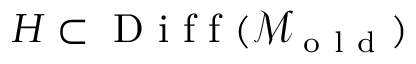<formula> <loc_0><loc_0><loc_500><loc_500>H \subset D i f f ( \mathcal { M } _ { o l d } )</formula> 